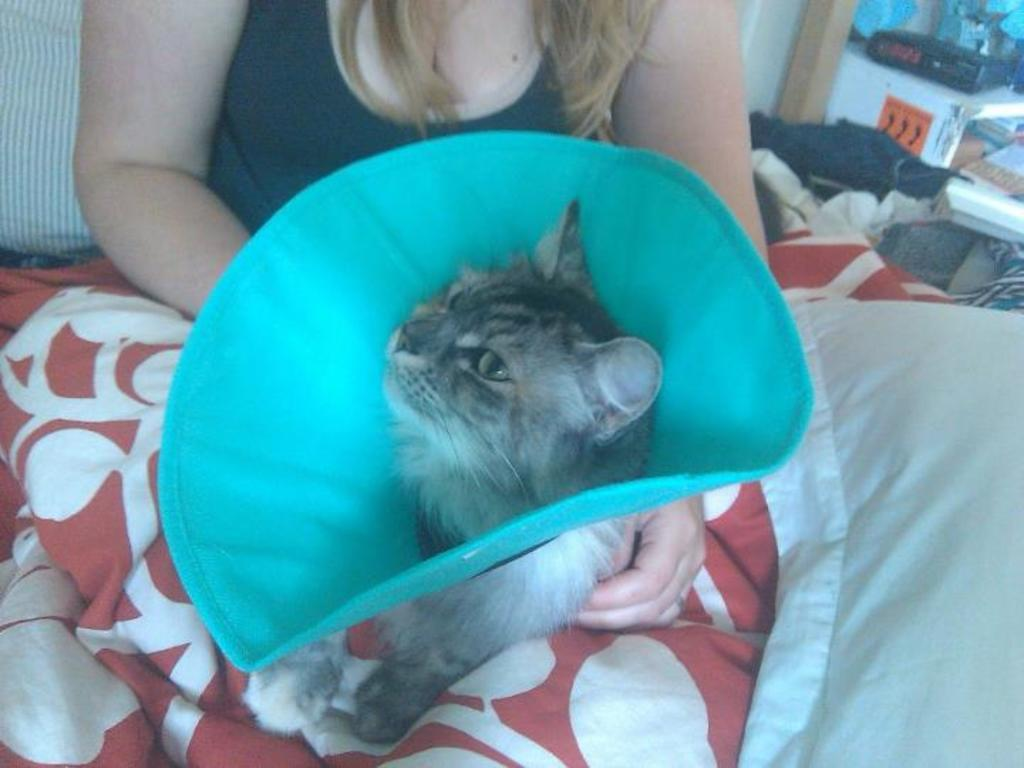What type of animal is in the image? There is a cat in the image. What is the person in the image wearing? There is a person in a black dress in the image. What object can be seen on the right side of the image? There is a pillow on the right side of the image. What type of authority does the cat have in the image? The cat does not have any authority in the image, as it is an animal and not a person. 